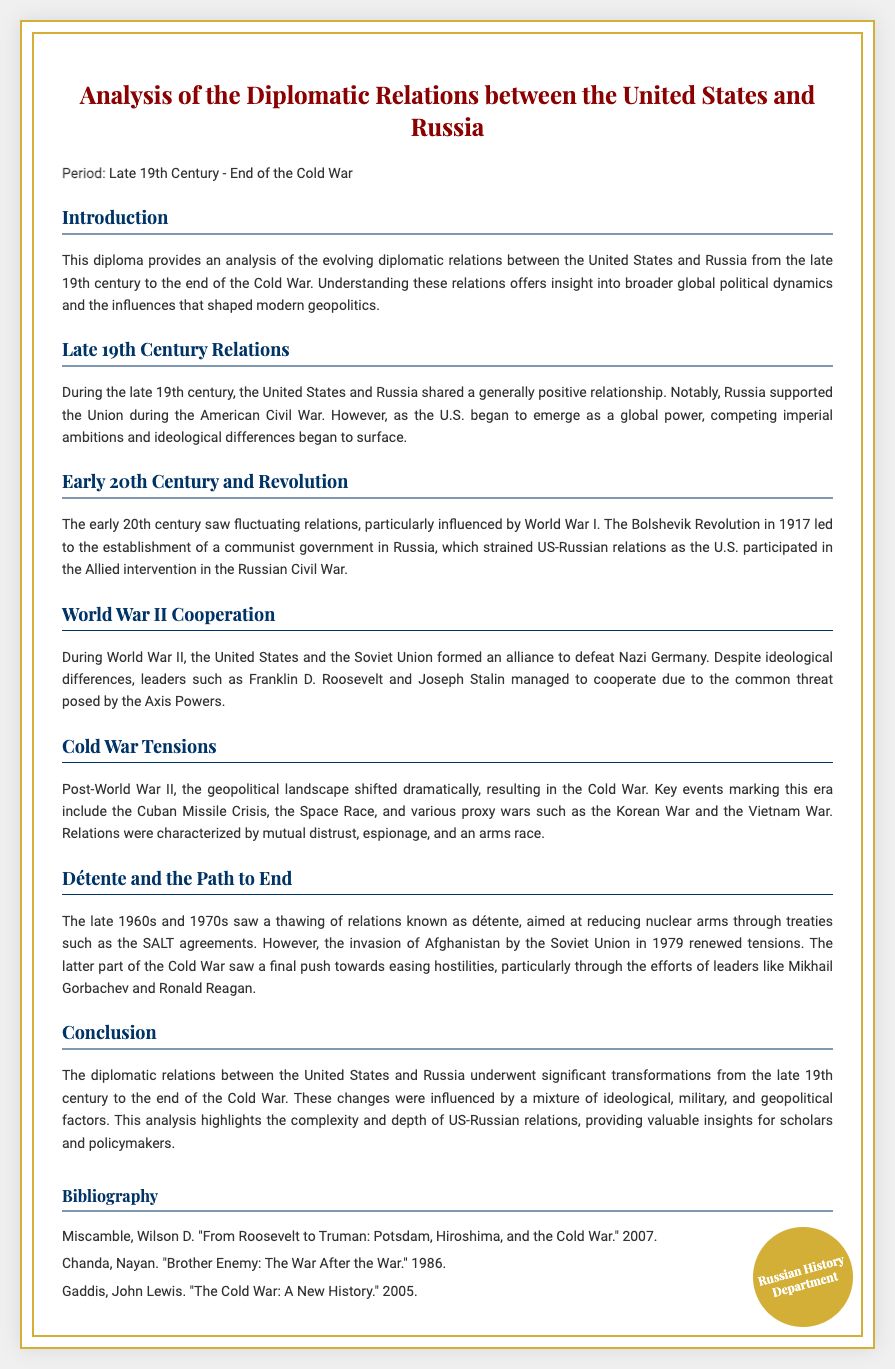What period does the diploma cover? The diploma covers the period from the late 19th century to the end of the Cold War.
Answer: Late 19th Century - End of the Cold War Who supported the Union during the American Civil War? The document states that Russia supported the Union during the American Civil War.
Answer: Russia What event led to the establishment of a communist government in Russia? The Bolshevik Revolution in 1917 led to the establishment of a communist government in Russia.
Answer: Bolshevik Revolution What was a major achievement of US-Soviet relations during World War II? The major achievement was the formation of an alliance between the United States and the Soviet Union to defeat Nazi Germany.
Answer: Alliance to defeat Nazi Germany Which treaty was aimed at reducing nuclear arms during détente? The SALT agreements were aimed at reducing nuclear arms during détente.
Answer: SALT agreements What event in 1979 renewed tensions in US-Russian relations? The invasion of Afghanistan by the Soviet Union in 1979 renewed tensions.
Answer: Invasion of Afghanistan Who were the two leaders mentioned as pivotal in easing hostilities towards the end of the Cold War? The document mentions Mikhail Gorbachev and Ronald Reagan as pivotal leaders.
Answer: Mikhail Gorbachev and Ronald Reagan Which chapter discusses the early 20th-century fluctuating relations? The chapter titled "Early 20th Century and Revolution" discusses this.
Answer: Early 20th Century and Revolution How many authors are referenced in the bibliography? There are three authors referenced in the bibliography.
Answer: Three 